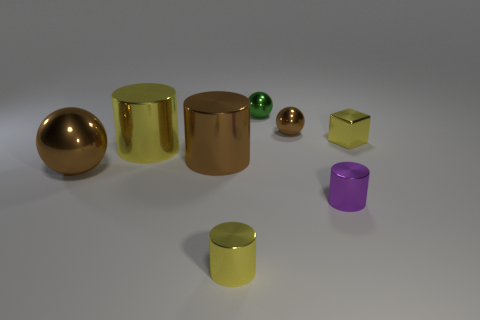Is the number of metallic spheres behind the small shiny block less than the number of tiny purple shiny things that are to the right of the small purple thing?
Offer a terse response. No. Is there another small block of the same color as the cube?
Provide a succinct answer. No. Does the tiny green object have the same material as the brown ball that is on the right side of the small green metal object?
Provide a short and direct response. Yes. There is a brown ball to the left of the small yellow shiny cylinder; is there a big brown cylinder that is to the left of it?
Ensure brevity in your answer.  No. What color is the shiny object that is on the right side of the green metal thing and behind the tiny yellow shiny block?
Offer a terse response. Brown. What is the size of the brown cylinder?
Ensure brevity in your answer.  Large. How many brown metal objects have the same size as the green object?
Keep it short and to the point. 1. Does the big object that is behind the brown shiny cylinder have the same material as the brown sphere that is behind the yellow metallic cube?
Your answer should be compact. Yes. There is a brown sphere that is to the right of the tiny yellow thing on the left side of the yellow block; what is it made of?
Provide a short and direct response. Metal. What is the yellow cylinder that is to the right of the large yellow cylinder made of?
Your answer should be compact. Metal. 